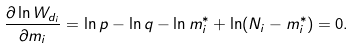Convert formula to latex. <formula><loc_0><loc_0><loc_500><loc_500>\frac { \partial \ln W _ { d _ { i } } } { \partial m _ { i } } = \ln p - \ln q - \ln m _ { i } ^ { * } + \ln ( N _ { i } - m _ { i } ^ { * } ) = 0 .</formula> 